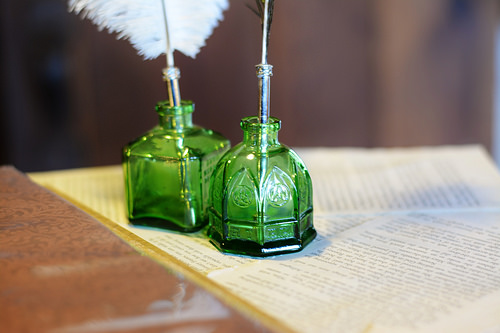<image>
Is there a quill in the jar? No. The quill is not contained within the jar. These objects have a different spatial relationship. 